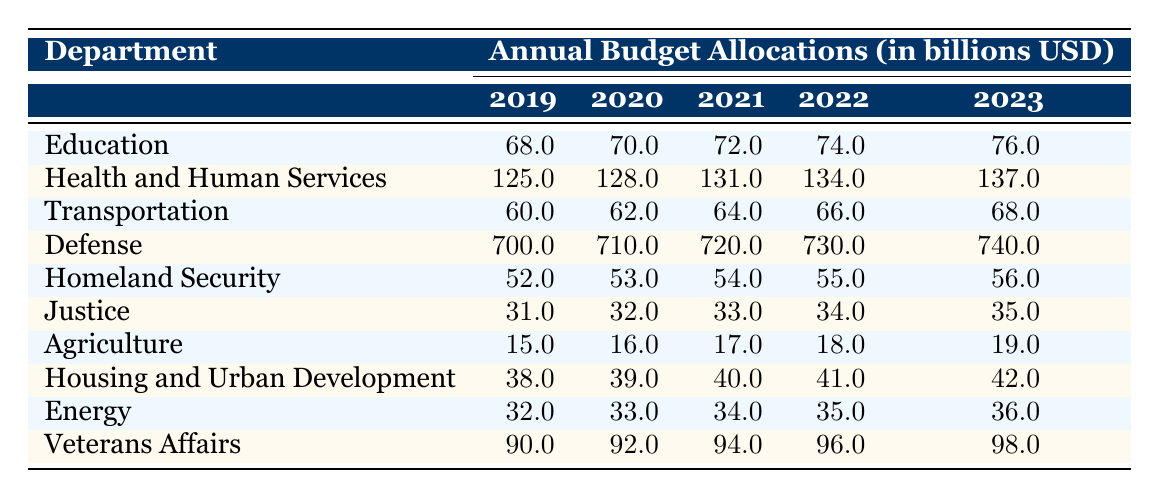What is the budget allocation for the Department of Education in 2021? The budget allocation for the Department of Education in 2021 is listed directly in the table. Looking under the '2021' column for the 'Department of Education' row, the value is 72.0 billion USD.
Answer: 72.0 billion USD Which department received the largest budget allocation in 2023? In 2023, each department's allocation can be found in the '2023' column. Comparing the values: 76.0 (Education), 137.0 (Health and Human Services), 68.0 (Transportation), 740.0 (Defense), 56.0 (Homeland Security), 35.0 (Justice), 19.0 (Agriculture), 42.0 (Housing and Urban Development), 36.0 (Energy), and 98.0 (Veterans Affairs), the largest allocation is 740.0 billion USD for the Department of Defense.
Answer: Department of Defense What is the average annual budget allocation for the Department of Agriculture from 2019 to 2023? To find the average, first sum the allocation values for the Department of Agriculture over the years: 15.0 + 16.0 + 17.0 + 18.0 + 19.0 = 85.0 billion USD. There are 5 data points, so the average is 85.0 / 5 = 17.0 billion USD.
Answer: 17.0 billion USD Did the Department of Health and Human Services have an increase in budget allocation from 2019 to 2023? By comparing the 2019 allocation (125.0 billion USD) to the 2023 allocation (137.0 billion USD) for the Department of Health and Human Services, it can be determined that the allocation increased by 12.0 billion USD over these years. Therefore, the answer is yes.
Answer: Yes What is the total budget allocation for all departments in 2022? To find the total budget allocation for 2022, sum the '2022' column for all departments: 74.0 (Education) + 134.0 (Health and Human Services) + 66.0 (Transportation) + 730.0 (Defense) + 55.0 (Homeland Security) + 34.0 (Justice) + 18.0 (Agriculture) + 41.0 (Housing and Urban Development) + 35.0 (Energy) + 96.0 (Veterans Affairs) =  1,000.0 billion USD.
Answer: 1,000.0 billion USD What was the budget allocation for the Department of Justice in 2019 compared to 2023? The budget allocation for the Department of Justice in 2019 is 31.0 billion USD, while in 2023 it is 35.0 billion USD. Therefore, the allocation increased over these years.
Answer: Increased 